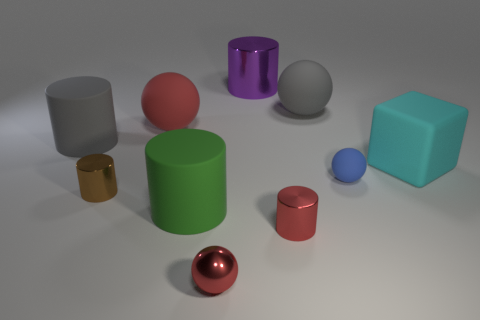There is a matte sphere on the left side of the metallic object behind the blue sphere; what size is it?
Provide a succinct answer. Large. Are there more cubes than big gray rubber things?
Make the answer very short. No. There is a red metallic ball in front of the red metal cylinder; is it the same size as the brown cylinder?
Give a very brief answer. Yes. What number of matte cylinders are the same color as the small rubber sphere?
Keep it short and to the point. 0. Is the green rubber thing the same shape as the large red object?
Make the answer very short. No. Is there any other thing that has the same size as the gray ball?
Make the answer very short. Yes. What is the size of the red metal object that is the same shape as the blue matte thing?
Offer a terse response. Small. Are there more small rubber objects that are on the right side of the tiny blue rubber sphere than large gray rubber things that are in front of the cyan cube?
Provide a short and direct response. No. Are the purple cylinder and the large gray object on the right side of the small red metal cylinder made of the same material?
Your answer should be very brief. No. Is there anything else that is the same shape as the large purple thing?
Your answer should be compact. Yes. 